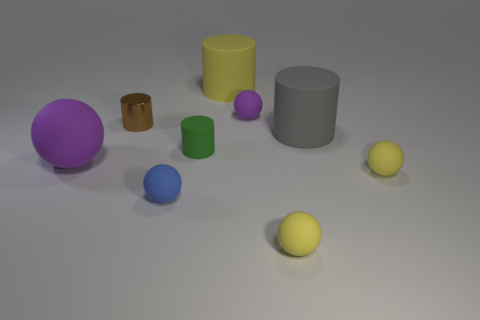Subtract 1 balls. How many balls are left? 4 Subtract all blue balls. How many balls are left? 4 Subtract all tiny blue balls. How many balls are left? 4 Subtract all red cylinders. Subtract all purple spheres. How many cylinders are left? 4 Subtract all spheres. How many objects are left? 4 Subtract 1 green cylinders. How many objects are left? 8 Subtract all small purple things. Subtract all small things. How many objects are left? 2 Add 4 large purple rubber spheres. How many large purple rubber spheres are left? 5 Add 6 green objects. How many green objects exist? 7 